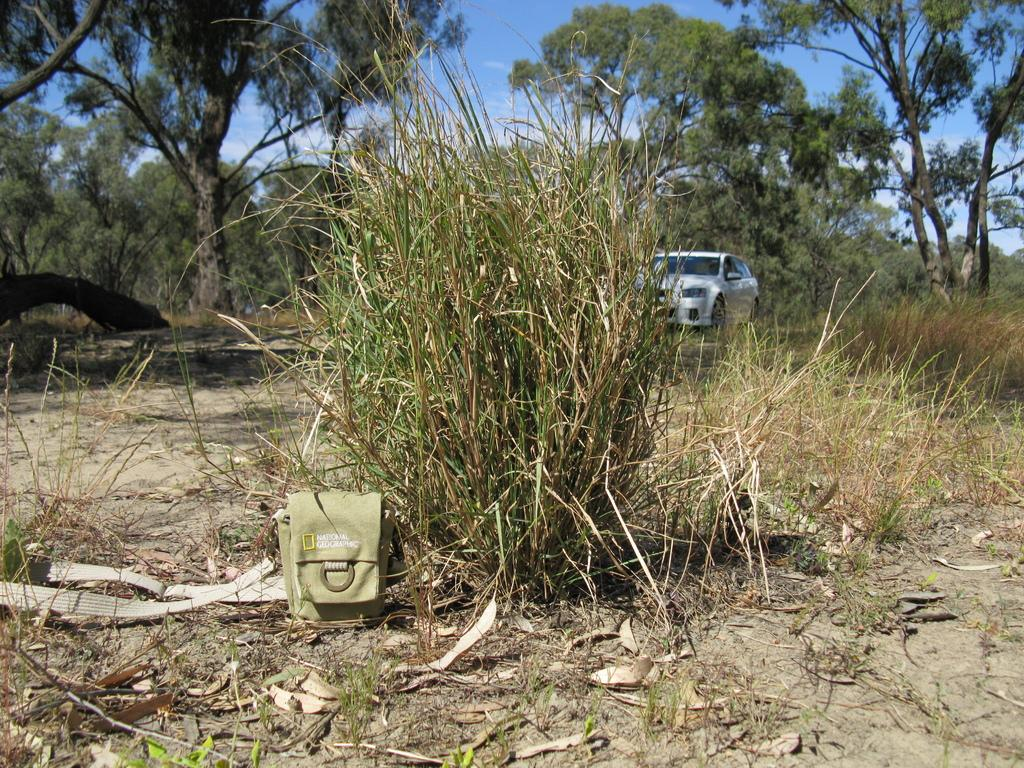What is the main subject of the image? There is a car in the image. Can you describe the car's appearance? The car is white in color. What type of natural environment can be seen in the image? There is grass visible in the image. What is present on the ground in the image? There is an object on the ground. What can be seen in the background of the image? There are trees and the sky visible in the background of the image. How many bananas are hanging from the trees in the image? There are no bananas visible in the image; only trees can be seen in the background. What type of rail is present in the image? There is no rail present in the image. 